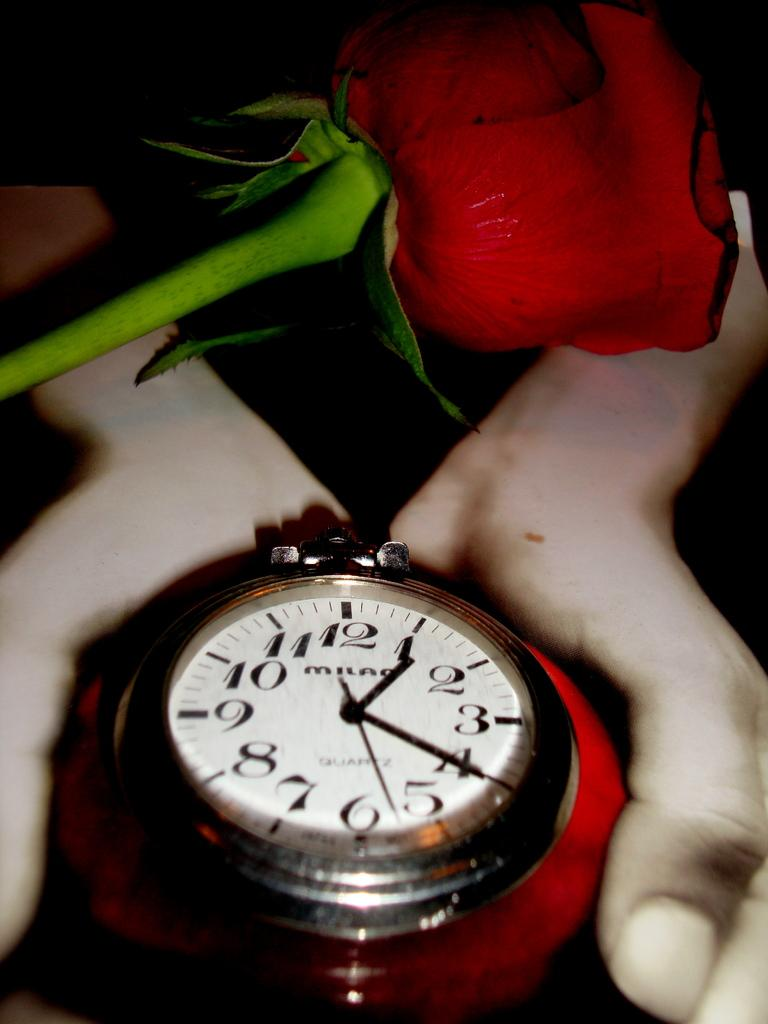<image>
Share a concise interpretation of the image provided. a pair of hands is holding a milan brand watch 